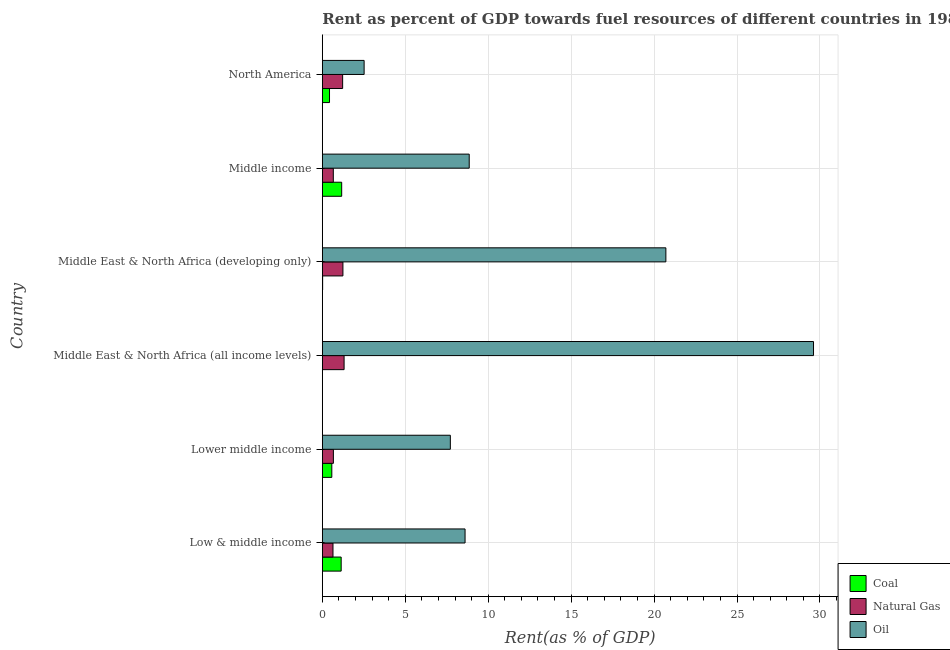How many different coloured bars are there?
Ensure brevity in your answer.  3. Are the number of bars per tick equal to the number of legend labels?
Your response must be concise. Yes. How many bars are there on the 6th tick from the bottom?
Offer a terse response. 3. What is the label of the 4th group of bars from the top?
Make the answer very short. Middle East & North Africa (all income levels). What is the rent towards coal in Middle East & North Africa (all income levels)?
Provide a short and direct response. 0.01. Across all countries, what is the maximum rent towards natural gas?
Offer a terse response. 1.31. Across all countries, what is the minimum rent towards coal?
Offer a very short reply. 0.01. In which country was the rent towards oil maximum?
Make the answer very short. Middle East & North Africa (all income levels). In which country was the rent towards natural gas minimum?
Make the answer very short. Low & middle income. What is the total rent towards natural gas in the graph?
Offer a very short reply. 5.75. What is the difference between the rent towards coal in Lower middle income and that in North America?
Give a very brief answer. 0.14. What is the difference between the rent towards natural gas in Low & middle income and the rent towards coal in Middle East & North Africa (all income levels)?
Your answer should be compact. 0.63. What is the average rent towards natural gas per country?
Make the answer very short. 0.96. What is the difference between the rent towards oil and rent towards coal in North America?
Your answer should be compact. 2.09. In how many countries, is the rent towards coal greater than 25 %?
Give a very brief answer. 0. What is the ratio of the rent towards oil in Low & middle income to that in Lower middle income?
Provide a short and direct response. 1.11. Is the rent towards natural gas in Lower middle income less than that in Middle East & North Africa (all income levels)?
Your response must be concise. Yes. Is the difference between the rent towards natural gas in Low & middle income and Middle East & North Africa (developing only) greater than the difference between the rent towards coal in Low & middle income and Middle East & North Africa (developing only)?
Offer a very short reply. No. What is the difference between the highest and the second highest rent towards coal?
Offer a very short reply. 0.03. What is the difference between the highest and the lowest rent towards oil?
Keep it short and to the point. 27.09. In how many countries, is the rent towards coal greater than the average rent towards coal taken over all countries?
Keep it short and to the point. 3. Is the sum of the rent towards coal in Low & middle income and Middle East & North Africa (all income levels) greater than the maximum rent towards natural gas across all countries?
Your answer should be very brief. No. What does the 1st bar from the top in Middle income represents?
Your response must be concise. Oil. What does the 1st bar from the bottom in Low & middle income represents?
Provide a short and direct response. Coal. How many bars are there?
Provide a succinct answer. 18. Are all the bars in the graph horizontal?
Offer a very short reply. Yes. Are the values on the major ticks of X-axis written in scientific E-notation?
Give a very brief answer. No. Does the graph contain any zero values?
Ensure brevity in your answer.  No. Where does the legend appear in the graph?
Offer a very short reply. Bottom right. How are the legend labels stacked?
Keep it short and to the point. Vertical. What is the title of the graph?
Keep it short and to the point. Rent as percent of GDP towards fuel resources of different countries in 1982. What is the label or title of the X-axis?
Ensure brevity in your answer.  Rent(as % of GDP). What is the label or title of the Y-axis?
Offer a very short reply. Country. What is the Rent(as % of GDP) of Coal in Low & middle income?
Make the answer very short. 1.14. What is the Rent(as % of GDP) of Natural Gas in Low & middle income?
Offer a terse response. 0.64. What is the Rent(as % of GDP) of Oil in Low & middle income?
Your answer should be very brief. 8.6. What is the Rent(as % of GDP) of Coal in Lower middle income?
Offer a terse response. 0.57. What is the Rent(as % of GDP) of Natural Gas in Lower middle income?
Keep it short and to the point. 0.67. What is the Rent(as % of GDP) of Oil in Lower middle income?
Make the answer very short. 7.72. What is the Rent(as % of GDP) in Coal in Middle East & North Africa (all income levels)?
Your response must be concise. 0.01. What is the Rent(as % of GDP) of Natural Gas in Middle East & North Africa (all income levels)?
Your response must be concise. 1.31. What is the Rent(as % of GDP) of Oil in Middle East & North Africa (all income levels)?
Give a very brief answer. 29.61. What is the Rent(as % of GDP) in Coal in Middle East & North Africa (developing only)?
Offer a very short reply. 0.02. What is the Rent(as % of GDP) in Natural Gas in Middle East & North Africa (developing only)?
Offer a terse response. 1.24. What is the Rent(as % of GDP) of Oil in Middle East & North Africa (developing only)?
Your response must be concise. 20.71. What is the Rent(as % of GDP) of Coal in Middle income?
Offer a terse response. 1.17. What is the Rent(as % of GDP) of Natural Gas in Middle income?
Keep it short and to the point. 0.66. What is the Rent(as % of GDP) in Oil in Middle income?
Offer a very short reply. 8.86. What is the Rent(as % of GDP) of Coal in North America?
Make the answer very short. 0.43. What is the Rent(as % of GDP) of Natural Gas in North America?
Make the answer very short. 1.22. What is the Rent(as % of GDP) of Oil in North America?
Your answer should be compact. 2.52. Across all countries, what is the maximum Rent(as % of GDP) in Coal?
Make the answer very short. 1.17. Across all countries, what is the maximum Rent(as % of GDP) of Natural Gas?
Offer a terse response. 1.31. Across all countries, what is the maximum Rent(as % of GDP) in Oil?
Provide a succinct answer. 29.61. Across all countries, what is the minimum Rent(as % of GDP) in Coal?
Give a very brief answer. 0.01. Across all countries, what is the minimum Rent(as % of GDP) of Natural Gas?
Make the answer very short. 0.64. Across all countries, what is the minimum Rent(as % of GDP) in Oil?
Offer a terse response. 2.52. What is the total Rent(as % of GDP) of Coal in the graph?
Offer a very short reply. 3.34. What is the total Rent(as % of GDP) of Natural Gas in the graph?
Keep it short and to the point. 5.75. What is the total Rent(as % of GDP) in Oil in the graph?
Provide a short and direct response. 78.02. What is the difference between the Rent(as % of GDP) of Coal in Low & middle income and that in Lower middle income?
Offer a very short reply. 0.56. What is the difference between the Rent(as % of GDP) in Natural Gas in Low & middle income and that in Lower middle income?
Offer a terse response. -0.02. What is the difference between the Rent(as % of GDP) in Oil in Low & middle income and that in Lower middle income?
Ensure brevity in your answer.  0.89. What is the difference between the Rent(as % of GDP) of Coal in Low & middle income and that in Middle East & North Africa (all income levels)?
Your answer should be compact. 1.13. What is the difference between the Rent(as % of GDP) of Natural Gas in Low & middle income and that in Middle East & North Africa (all income levels)?
Your answer should be very brief. -0.67. What is the difference between the Rent(as % of GDP) of Oil in Low & middle income and that in Middle East & North Africa (all income levels)?
Offer a very short reply. -21.01. What is the difference between the Rent(as % of GDP) of Coal in Low & middle income and that in Middle East & North Africa (developing only)?
Your response must be concise. 1.12. What is the difference between the Rent(as % of GDP) in Natural Gas in Low & middle income and that in Middle East & North Africa (developing only)?
Give a very brief answer. -0.6. What is the difference between the Rent(as % of GDP) of Oil in Low & middle income and that in Middle East & North Africa (developing only)?
Your answer should be compact. -12.11. What is the difference between the Rent(as % of GDP) of Coal in Low & middle income and that in Middle income?
Keep it short and to the point. -0.03. What is the difference between the Rent(as % of GDP) in Natural Gas in Low & middle income and that in Middle income?
Keep it short and to the point. -0.02. What is the difference between the Rent(as % of GDP) in Oil in Low & middle income and that in Middle income?
Provide a short and direct response. -0.25. What is the difference between the Rent(as % of GDP) in Coal in Low & middle income and that in North America?
Offer a very short reply. 0.7. What is the difference between the Rent(as % of GDP) in Natural Gas in Low & middle income and that in North America?
Offer a terse response. -0.58. What is the difference between the Rent(as % of GDP) in Oil in Low & middle income and that in North America?
Offer a very short reply. 6.08. What is the difference between the Rent(as % of GDP) in Coal in Lower middle income and that in Middle East & North Africa (all income levels)?
Your response must be concise. 0.56. What is the difference between the Rent(as % of GDP) in Natural Gas in Lower middle income and that in Middle East & North Africa (all income levels)?
Your response must be concise. -0.64. What is the difference between the Rent(as % of GDP) of Oil in Lower middle income and that in Middle East & North Africa (all income levels)?
Provide a short and direct response. -21.89. What is the difference between the Rent(as % of GDP) in Coal in Lower middle income and that in Middle East & North Africa (developing only)?
Your response must be concise. 0.55. What is the difference between the Rent(as % of GDP) of Natural Gas in Lower middle income and that in Middle East & North Africa (developing only)?
Ensure brevity in your answer.  -0.57. What is the difference between the Rent(as % of GDP) of Oil in Lower middle income and that in Middle East & North Africa (developing only)?
Make the answer very short. -12.99. What is the difference between the Rent(as % of GDP) of Coal in Lower middle income and that in Middle income?
Your answer should be very brief. -0.6. What is the difference between the Rent(as % of GDP) in Natural Gas in Lower middle income and that in Middle income?
Offer a very short reply. 0. What is the difference between the Rent(as % of GDP) in Oil in Lower middle income and that in Middle income?
Offer a terse response. -1.14. What is the difference between the Rent(as % of GDP) of Coal in Lower middle income and that in North America?
Keep it short and to the point. 0.14. What is the difference between the Rent(as % of GDP) of Natural Gas in Lower middle income and that in North America?
Your answer should be very brief. -0.56. What is the difference between the Rent(as % of GDP) in Oil in Lower middle income and that in North America?
Your answer should be very brief. 5.2. What is the difference between the Rent(as % of GDP) of Coal in Middle East & North Africa (all income levels) and that in Middle East & North Africa (developing only)?
Your answer should be compact. -0.01. What is the difference between the Rent(as % of GDP) in Natural Gas in Middle East & North Africa (all income levels) and that in Middle East & North Africa (developing only)?
Provide a short and direct response. 0.07. What is the difference between the Rent(as % of GDP) in Oil in Middle East & North Africa (all income levels) and that in Middle East & North Africa (developing only)?
Keep it short and to the point. 8.9. What is the difference between the Rent(as % of GDP) in Coal in Middle East & North Africa (all income levels) and that in Middle income?
Offer a very short reply. -1.16. What is the difference between the Rent(as % of GDP) of Natural Gas in Middle East & North Africa (all income levels) and that in Middle income?
Provide a succinct answer. 0.65. What is the difference between the Rent(as % of GDP) of Oil in Middle East & North Africa (all income levels) and that in Middle income?
Provide a succinct answer. 20.76. What is the difference between the Rent(as % of GDP) of Coal in Middle East & North Africa (all income levels) and that in North America?
Make the answer very short. -0.42. What is the difference between the Rent(as % of GDP) of Natural Gas in Middle East & North Africa (all income levels) and that in North America?
Ensure brevity in your answer.  0.09. What is the difference between the Rent(as % of GDP) of Oil in Middle East & North Africa (all income levels) and that in North America?
Offer a terse response. 27.09. What is the difference between the Rent(as % of GDP) in Coal in Middle East & North Africa (developing only) and that in Middle income?
Offer a very short reply. -1.15. What is the difference between the Rent(as % of GDP) of Natural Gas in Middle East & North Africa (developing only) and that in Middle income?
Your answer should be very brief. 0.58. What is the difference between the Rent(as % of GDP) in Oil in Middle East & North Africa (developing only) and that in Middle income?
Give a very brief answer. 11.85. What is the difference between the Rent(as % of GDP) in Coal in Middle East & North Africa (developing only) and that in North America?
Provide a succinct answer. -0.41. What is the difference between the Rent(as % of GDP) in Natural Gas in Middle East & North Africa (developing only) and that in North America?
Ensure brevity in your answer.  0.02. What is the difference between the Rent(as % of GDP) of Oil in Middle East & North Africa (developing only) and that in North America?
Provide a succinct answer. 18.19. What is the difference between the Rent(as % of GDP) of Coal in Middle income and that in North America?
Provide a short and direct response. 0.73. What is the difference between the Rent(as % of GDP) of Natural Gas in Middle income and that in North America?
Offer a very short reply. -0.56. What is the difference between the Rent(as % of GDP) in Oil in Middle income and that in North America?
Offer a terse response. 6.34. What is the difference between the Rent(as % of GDP) in Coal in Low & middle income and the Rent(as % of GDP) in Natural Gas in Lower middle income?
Provide a succinct answer. 0.47. What is the difference between the Rent(as % of GDP) in Coal in Low & middle income and the Rent(as % of GDP) in Oil in Lower middle income?
Make the answer very short. -6.58. What is the difference between the Rent(as % of GDP) of Natural Gas in Low & middle income and the Rent(as % of GDP) of Oil in Lower middle income?
Offer a terse response. -7.08. What is the difference between the Rent(as % of GDP) of Coal in Low & middle income and the Rent(as % of GDP) of Natural Gas in Middle East & North Africa (all income levels)?
Your answer should be compact. -0.18. What is the difference between the Rent(as % of GDP) of Coal in Low & middle income and the Rent(as % of GDP) of Oil in Middle East & North Africa (all income levels)?
Your answer should be very brief. -28.47. What is the difference between the Rent(as % of GDP) of Natural Gas in Low & middle income and the Rent(as % of GDP) of Oil in Middle East & North Africa (all income levels)?
Your answer should be very brief. -28.97. What is the difference between the Rent(as % of GDP) in Coal in Low & middle income and the Rent(as % of GDP) in Natural Gas in Middle East & North Africa (developing only)?
Your response must be concise. -0.1. What is the difference between the Rent(as % of GDP) in Coal in Low & middle income and the Rent(as % of GDP) in Oil in Middle East & North Africa (developing only)?
Keep it short and to the point. -19.57. What is the difference between the Rent(as % of GDP) in Natural Gas in Low & middle income and the Rent(as % of GDP) in Oil in Middle East & North Africa (developing only)?
Ensure brevity in your answer.  -20.07. What is the difference between the Rent(as % of GDP) of Coal in Low & middle income and the Rent(as % of GDP) of Natural Gas in Middle income?
Provide a succinct answer. 0.47. What is the difference between the Rent(as % of GDP) in Coal in Low & middle income and the Rent(as % of GDP) in Oil in Middle income?
Provide a succinct answer. -7.72. What is the difference between the Rent(as % of GDP) of Natural Gas in Low & middle income and the Rent(as % of GDP) of Oil in Middle income?
Give a very brief answer. -8.21. What is the difference between the Rent(as % of GDP) in Coal in Low & middle income and the Rent(as % of GDP) in Natural Gas in North America?
Keep it short and to the point. -0.09. What is the difference between the Rent(as % of GDP) in Coal in Low & middle income and the Rent(as % of GDP) in Oil in North America?
Offer a terse response. -1.38. What is the difference between the Rent(as % of GDP) of Natural Gas in Low & middle income and the Rent(as % of GDP) of Oil in North America?
Keep it short and to the point. -1.88. What is the difference between the Rent(as % of GDP) of Coal in Lower middle income and the Rent(as % of GDP) of Natural Gas in Middle East & North Africa (all income levels)?
Make the answer very short. -0.74. What is the difference between the Rent(as % of GDP) of Coal in Lower middle income and the Rent(as % of GDP) of Oil in Middle East & North Africa (all income levels)?
Provide a short and direct response. -29.04. What is the difference between the Rent(as % of GDP) of Natural Gas in Lower middle income and the Rent(as % of GDP) of Oil in Middle East & North Africa (all income levels)?
Make the answer very short. -28.94. What is the difference between the Rent(as % of GDP) in Coal in Lower middle income and the Rent(as % of GDP) in Natural Gas in Middle East & North Africa (developing only)?
Your response must be concise. -0.67. What is the difference between the Rent(as % of GDP) in Coal in Lower middle income and the Rent(as % of GDP) in Oil in Middle East & North Africa (developing only)?
Offer a very short reply. -20.14. What is the difference between the Rent(as % of GDP) in Natural Gas in Lower middle income and the Rent(as % of GDP) in Oil in Middle East & North Africa (developing only)?
Provide a short and direct response. -20.04. What is the difference between the Rent(as % of GDP) of Coal in Lower middle income and the Rent(as % of GDP) of Natural Gas in Middle income?
Offer a very short reply. -0.09. What is the difference between the Rent(as % of GDP) of Coal in Lower middle income and the Rent(as % of GDP) of Oil in Middle income?
Ensure brevity in your answer.  -8.28. What is the difference between the Rent(as % of GDP) in Natural Gas in Lower middle income and the Rent(as % of GDP) in Oil in Middle income?
Make the answer very short. -8.19. What is the difference between the Rent(as % of GDP) of Coal in Lower middle income and the Rent(as % of GDP) of Natural Gas in North America?
Your answer should be very brief. -0.65. What is the difference between the Rent(as % of GDP) in Coal in Lower middle income and the Rent(as % of GDP) in Oil in North America?
Offer a very short reply. -1.95. What is the difference between the Rent(as % of GDP) of Natural Gas in Lower middle income and the Rent(as % of GDP) of Oil in North America?
Make the answer very short. -1.85. What is the difference between the Rent(as % of GDP) of Coal in Middle East & North Africa (all income levels) and the Rent(as % of GDP) of Natural Gas in Middle East & North Africa (developing only)?
Provide a succinct answer. -1.23. What is the difference between the Rent(as % of GDP) of Coal in Middle East & North Africa (all income levels) and the Rent(as % of GDP) of Oil in Middle East & North Africa (developing only)?
Offer a terse response. -20.7. What is the difference between the Rent(as % of GDP) of Natural Gas in Middle East & North Africa (all income levels) and the Rent(as % of GDP) of Oil in Middle East & North Africa (developing only)?
Your response must be concise. -19.4. What is the difference between the Rent(as % of GDP) in Coal in Middle East & North Africa (all income levels) and the Rent(as % of GDP) in Natural Gas in Middle income?
Offer a very short reply. -0.65. What is the difference between the Rent(as % of GDP) of Coal in Middle East & North Africa (all income levels) and the Rent(as % of GDP) of Oil in Middle income?
Provide a succinct answer. -8.85. What is the difference between the Rent(as % of GDP) in Natural Gas in Middle East & North Africa (all income levels) and the Rent(as % of GDP) in Oil in Middle income?
Offer a very short reply. -7.54. What is the difference between the Rent(as % of GDP) of Coal in Middle East & North Africa (all income levels) and the Rent(as % of GDP) of Natural Gas in North America?
Make the answer very short. -1.22. What is the difference between the Rent(as % of GDP) of Coal in Middle East & North Africa (all income levels) and the Rent(as % of GDP) of Oil in North America?
Give a very brief answer. -2.51. What is the difference between the Rent(as % of GDP) in Natural Gas in Middle East & North Africa (all income levels) and the Rent(as % of GDP) in Oil in North America?
Keep it short and to the point. -1.21. What is the difference between the Rent(as % of GDP) in Coal in Middle East & North Africa (developing only) and the Rent(as % of GDP) in Natural Gas in Middle income?
Your response must be concise. -0.64. What is the difference between the Rent(as % of GDP) of Coal in Middle East & North Africa (developing only) and the Rent(as % of GDP) of Oil in Middle income?
Make the answer very short. -8.84. What is the difference between the Rent(as % of GDP) of Natural Gas in Middle East & North Africa (developing only) and the Rent(as % of GDP) of Oil in Middle income?
Offer a terse response. -7.61. What is the difference between the Rent(as % of GDP) in Coal in Middle East & North Africa (developing only) and the Rent(as % of GDP) in Natural Gas in North America?
Offer a terse response. -1.21. What is the difference between the Rent(as % of GDP) in Coal in Middle East & North Africa (developing only) and the Rent(as % of GDP) in Oil in North America?
Provide a succinct answer. -2.5. What is the difference between the Rent(as % of GDP) of Natural Gas in Middle East & North Africa (developing only) and the Rent(as % of GDP) of Oil in North America?
Ensure brevity in your answer.  -1.28. What is the difference between the Rent(as % of GDP) of Coal in Middle income and the Rent(as % of GDP) of Natural Gas in North America?
Give a very brief answer. -0.06. What is the difference between the Rent(as % of GDP) in Coal in Middle income and the Rent(as % of GDP) in Oil in North America?
Offer a very short reply. -1.35. What is the difference between the Rent(as % of GDP) in Natural Gas in Middle income and the Rent(as % of GDP) in Oil in North America?
Offer a terse response. -1.86. What is the average Rent(as % of GDP) of Coal per country?
Give a very brief answer. 0.56. What is the average Rent(as % of GDP) in Natural Gas per country?
Provide a short and direct response. 0.96. What is the average Rent(as % of GDP) of Oil per country?
Provide a short and direct response. 13. What is the difference between the Rent(as % of GDP) in Coal and Rent(as % of GDP) in Natural Gas in Low & middle income?
Your response must be concise. 0.49. What is the difference between the Rent(as % of GDP) in Coal and Rent(as % of GDP) in Oil in Low & middle income?
Ensure brevity in your answer.  -7.47. What is the difference between the Rent(as % of GDP) in Natural Gas and Rent(as % of GDP) in Oil in Low & middle income?
Make the answer very short. -7.96. What is the difference between the Rent(as % of GDP) of Coal and Rent(as % of GDP) of Natural Gas in Lower middle income?
Give a very brief answer. -0.1. What is the difference between the Rent(as % of GDP) of Coal and Rent(as % of GDP) of Oil in Lower middle income?
Your answer should be very brief. -7.15. What is the difference between the Rent(as % of GDP) of Natural Gas and Rent(as % of GDP) of Oil in Lower middle income?
Keep it short and to the point. -7.05. What is the difference between the Rent(as % of GDP) in Coal and Rent(as % of GDP) in Natural Gas in Middle East & North Africa (all income levels)?
Offer a terse response. -1.3. What is the difference between the Rent(as % of GDP) in Coal and Rent(as % of GDP) in Oil in Middle East & North Africa (all income levels)?
Make the answer very short. -29.6. What is the difference between the Rent(as % of GDP) of Natural Gas and Rent(as % of GDP) of Oil in Middle East & North Africa (all income levels)?
Ensure brevity in your answer.  -28.3. What is the difference between the Rent(as % of GDP) of Coal and Rent(as % of GDP) of Natural Gas in Middle East & North Africa (developing only)?
Offer a terse response. -1.22. What is the difference between the Rent(as % of GDP) in Coal and Rent(as % of GDP) in Oil in Middle East & North Africa (developing only)?
Your answer should be compact. -20.69. What is the difference between the Rent(as % of GDP) in Natural Gas and Rent(as % of GDP) in Oil in Middle East & North Africa (developing only)?
Your answer should be compact. -19.47. What is the difference between the Rent(as % of GDP) in Coal and Rent(as % of GDP) in Natural Gas in Middle income?
Provide a short and direct response. 0.51. What is the difference between the Rent(as % of GDP) of Coal and Rent(as % of GDP) of Oil in Middle income?
Keep it short and to the point. -7.69. What is the difference between the Rent(as % of GDP) of Natural Gas and Rent(as % of GDP) of Oil in Middle income?
Offer a terse response. -8.19. What is the difference between the Rent(as % of GDP) of Coal and Rent(as % of GDP) of Natural Gas in North America?
Keep it short and to the point. -0.79. What is the difference between the Rent(as % of GDP) in Coal and Rent(as % of GDP) in Oil in North America?
Offer a terse response. -2.09. What is the difference between the Rent(as % of GDP) in Natural Gas and Rent(as % of GDP) in Oil in North America?
Your response must be concise. -1.3. What is the ratio of the Rent(as % of GDP) of Coal in Low & middle income to that in Lower middle income?
Provide a succinct answer. 1.99. What is the ratio of the Rent(as % of GDP) of Natural Gas in Low & middle income to that in Lower middle income?
Your response must be concise. 0.96. What is the ratio of the Rent(as % of GDP) of Oil in Low & middle income to that in Lower middle income?
Make the answer very short. 1.11. What is the ratio of the Rent(as % of GDP) of Coal in Low & middle income to that in Middle East & North Africa (all income levels)?
Your answer should be compact. 118.39. What is the ratio of the Rent(as % of GDP) of Natural Gas in Low & middle income to that in Middle East & North Africa (all income levels)?
Your answer should be very brief. 0.49. What is the ratio of the Rent(as % of GDP) of Oil in Low & middle income to that in Middle East & North Africa (all income levels)?
Your answer should be compact. 0.29. What is the ratio of the Rent(as % of GDP) of Coal in Low & middle income to that in Middle East & North Africa (developing only)?
Offer a terse response. 61.29. What is the ratio of the Rent(as % of GDP) of Natural Gas in Low & middle income to that in Middle East & North Africa (developing only)?
Ensure brevity in your answer.  0.52. What is the ratio of the Rent(as % of GDP) in Oil in Low & middle income to that in Middle East & North Africa (developing only)?
Give a very brief answer. 0.42. What is the ratio of the Rent(as % of GDP) of Coal in Low & middle income to that in Middle income?
Your answer should be compact. 0.97. What is the ratio of the Rent(as % of GDP) of Natural Gas in Low & middle income to that in Middle income?
Your answer should be very brief. 0.97. What is the ratio of the Rent(as % of GDP) of Oil in Low & middle income to that in Middle income?
Offer a terse response. 0.97. What is the ratio of the Rent(as % of GDP) in Coal in Low & middle income to that in North America?
Offer a very short reply. 2.62. What is the ratio of the Rent(as % of GDP) in Natural Gas in Low & middle income to that in North America?
Your response must be concise. 0.52. What is the ratio of the Rent(as % of GDP) of Oil in Low & middle income to that in North America?
Your answer should be compact. 3.41. What is the ratio of the Rent(as % of GDP) in Coal in Lower middle income to that in Middle East & North Africa (all income levels)?
Make the answer very short. 59.54. What is the ratio of the Rent(as % of GDP) of Natural Gas in Lower middle income to that in Middle East & North Africa (all income levels)?
Your answer should be compact. 0.51. What is the ratio of the Rent(as % of GDP) of Oil in Lower middle income to that in Middle East & North Africa (all income levels)?
Ensure brevity in your answer.  0.26. What is the ratio of the Rent(as % of GDP) in Coal in Lower middle income to that in Middle East & North Africa (developing only)?
Provide a short and direct response. 30.82. What is the ratio of the Rent(as % of GDP) of Natural Gas in Lower middle income to that in Middle East & North Africa (developing only)?
Offer a terse response. 0.54. What is the ratio of the Rent(as % of GDP) in Oil in Lower middle income to that in Middle East & North Africa (developing only)?
Your response must be concise. 0.37. What is the ratio of the Rent(as % of GDP) in Coal in Lower middle income to that in Middle income?
Provide a short and direct response. 0.49. What is the ratio of the Rent(as % of GDP) in Natural Gas in Lower middle income to that in Middle income?
Provide a short and direct response. 1.01. What is the ratio of the Rent(as % of GDP) in Oil in Lower middle income to that in Middle income?
Give a very brief answer. 0.87. What is the ratio of the Rent(as % of GDP) in Coal in Lower middle income to that in North America?
Offer a terse response. 1.32. What is the ratio of the Rent(as % of GDP) in Natural Gas in Lower middle income to that in North America?
Keep it short and to the point. 0.54. What is the ratio of the Rent(as % of GDP) of Oil in Lower middle income to that in North America?
Ensure brevity in your answer.  3.06. What is the ratio of the Rent(as % of GDP) of Coal in Middle East & North Africa (all income levels) to that in Middle East & North Africa (developing only)?
Ensure brevity in your answer.  0.52. What is the ratio of the Rent(as % of GDP) of Natural Gas in Middle East & North Africa (all income levels) to that in Middle East & North Africa (developing only)?
Provide a succinct answer. 1.06. What is the ratio of the Rent(as % of GDP) of Oil in Middle East & North Africa (all income levels) to that in Middle East & North Africa (developing only)?
Your answer should be compact. 1.43. What is the ratio of the Rent(as % of GDP) in Coal in Middle East & North Africa (all income levels) to that in Middle income?
Ensure brevity in your answer.  0.01. What is the ratio of the Rent(as % of GDP) in Natural Gas in Middle East & North Africa (all income levels) to that in Middle income?
Your answer should be very brief. 1.98. What is the ratio of the Rent(as % of GDP) in Oil in Middle East & North Africa (all income levels) to that in Middle income?
Your answer should be compact. 3.34. What is the ratio of the Rent(as % of GDP) of Coal in Middle East & North Africa (all income levels) to that in North America?
Give a very brief answer. 0.02. What is the ratio of the Rent(as % of GDP) of Natural Gas in Middle East & North Africa (all income levels) to that in North America?
Your answer should be very brief. 1.07. What is the ratio of the Rent(as % of GDP) of Oil in Middle East & North Africa (all income levels) to that in North America?
Ensure brevity in your answer.  11.75. What is the ratio of the Rent(as % of GDP) in Coal in Middle East & North Africa (developing only) to that in Middle income?
Your response must be concise. 0.02. What is the ratio of the Rent(as % of GDP) of Natural Gas in Middle East & North Africa (developing only) to that in Middle income?
Offer a very short reply. 1.87. What is the ratio of the Rent(as % of GDP) of Oil in Middle East & North Africa (developing only) to that in Middle income?
Make the answer very short. 2.34. What is the ratio of the Rent(as % of GDP) of Coal in Middle East & North Africa (developing only) to that in North America?
Ensure brevity in your answer.  0.04. What is the ratio of the Rent(as % of GDP) in Natural Gas in Middle East & North Africa (developing only) to that in North America?
Make the answer very short. 1.01. What is the ratio of the Rent(as % of GDP) in Oil in Middle East & North Africa (developing only) to that in North America?
Make the answer very short. 8.22. What is the ratio of the Rent(as % of GDP) of Coal in Middle income to that in North America?
Your response must be concise. 2.69. What is the ratio of the Rent(as % of GDP) of Natural Gas in Middle income to that in North America?
Your answer should be compact. 0.54. What is the ratio of the Rent(as % of GDP) of Oil in Middle income to that in North America?
Provide a succinct answer. 3.51. What is the difference between the highest and the second highest Rent(as % of GDP) in Coal?
Your response must be concise. 0.03. What is the difference between the highest and the second highest Rent(as % of GDP) of Natural Gas?
Ensure brevity in your answer.  0.07. What is the difference between the highest and the second highest Rent(as % of GDP) in Oil?
Your response must be concise. 8.9. What is the difference between the highest and the lowest Rent(as % of GDP) of Coal?
Make the answer very short. 1.16. What is the difference between the highest and the lowest Rent(as % of GDP) of Natural Gas?
Give a very brief answer. 0.67. What is the difference between the highest and the lowest Rent(as % of GDP) in Oil?
Offer a very short reply. 27.09. 